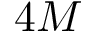<formula> <loc_0><loc_0><loc_500><loc_500>4 M</formula> 